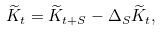<formula> <loc_0><loc_0><loc_500><loc_500>\widetilde { K } _ { t } = \widetilde { K } _ { t + S } - \Delta _ { S } \widetilde { K } _ { t } ,</formula> 